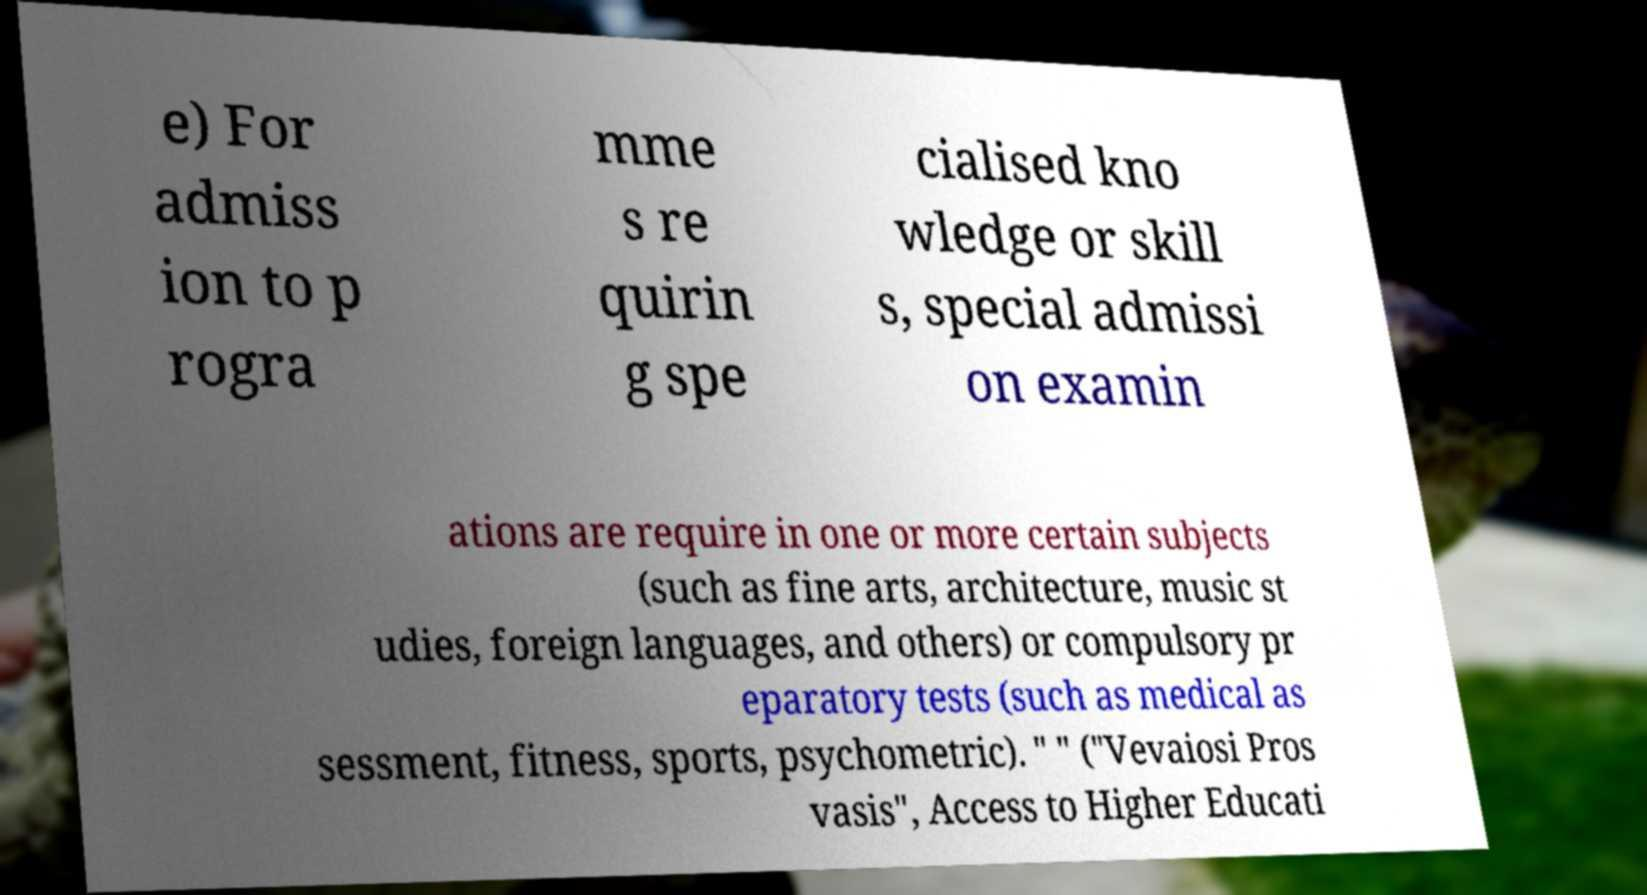Can you accurately transcribe the text from the provided image for me? e) For admiss ion to p rogra mme s re quirin g spe cialised kno wledge or skill s, special admissi on examin ations are require in one or more certain subjects (such as fine arts, architecture, music st udies, foreign languages, and others) or compulsory pr eparatory tests (such as medical as sessment, fitness, sports, psychometric). " " ("Vevaiosi Pros vasis", Access to Higher Educati 